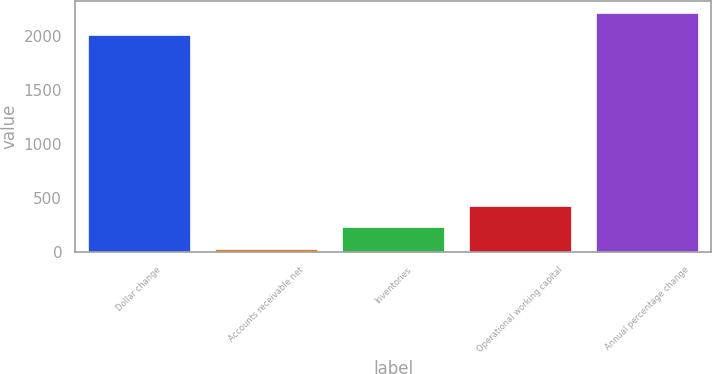Convert chart. <chart><loc_0><loc_0><loc_500><loc_500><bar_chart><fcel>Dollar change<fcel>Accounts receivable net<fcel>Inventories<fcel>Operational working capital<fcel>Annual percentage change<nl><fcel>2016<fcel>31.3<fcel>229.77<fcel>428.24<fcel>2214.47<nl></chart> 